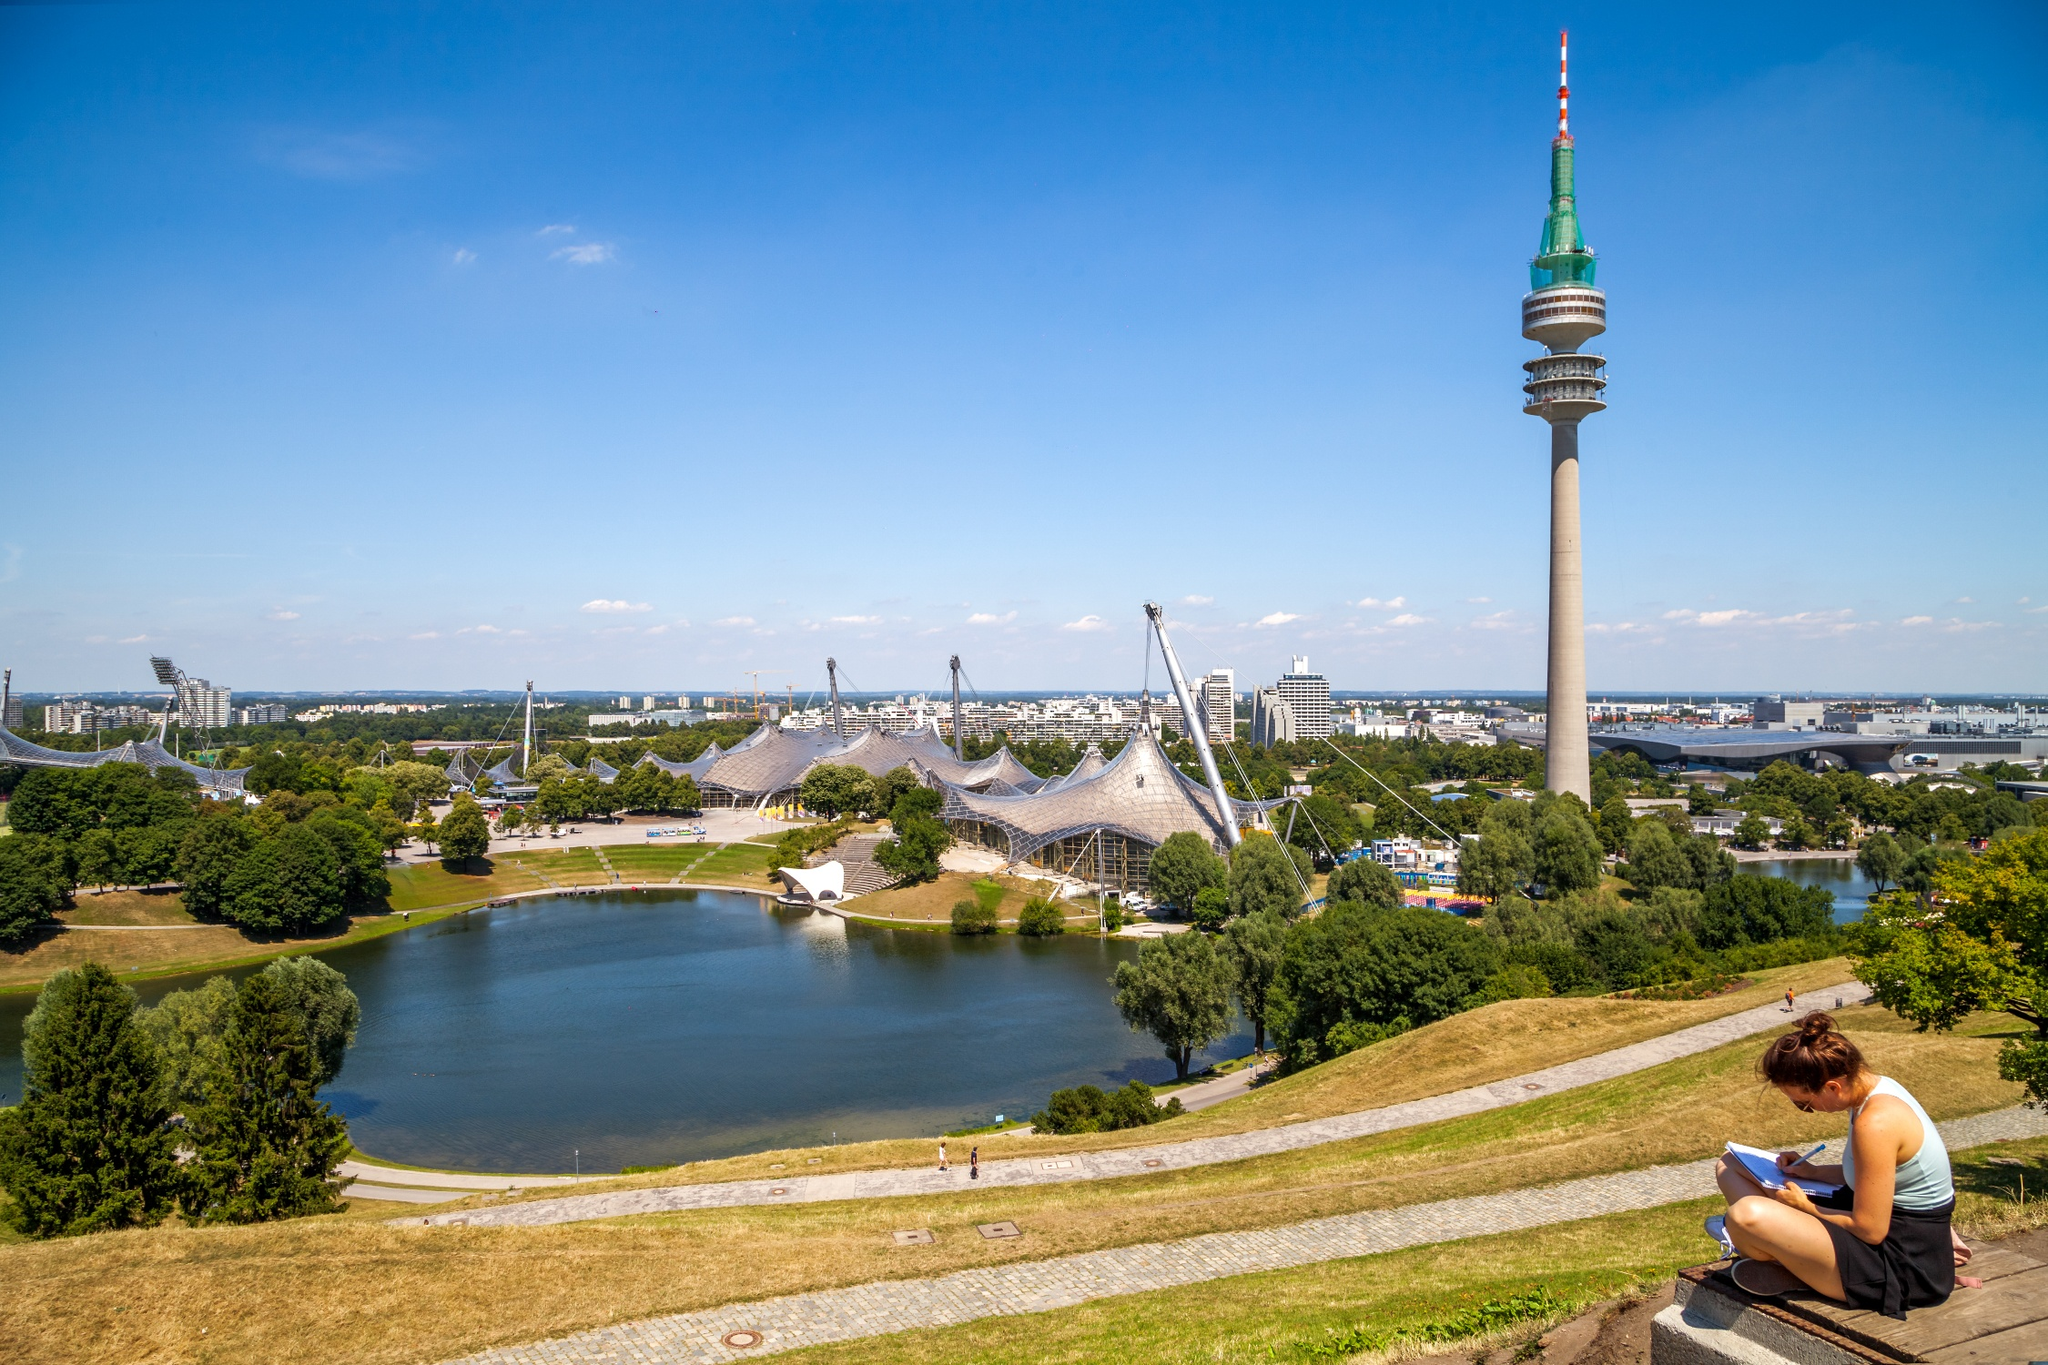Describe a typical day in this park. A typical day in the Olympic Park starts with the gentle rustle of leaves and the distant hum of city life. Early in the morning, joggers take to the paths winding through the greenery, while others engage in serene yoga sessions by the lake. The park gradually comes to life as families, tourists, and students arrive. Throughout the day, the open spaces host picnics and games, while visitors explore the architectural grandeur of the Olympic Stadium and Tower. By the afternoon, the benches are occupied by readers, the lake sees swan boats gliding over its calm surface, and photographers capture the panoramic views. As evening descends, the park becomes a lively venue for concerts and events, wrapping up with a peaceful, quiet night under the starlit sky. 